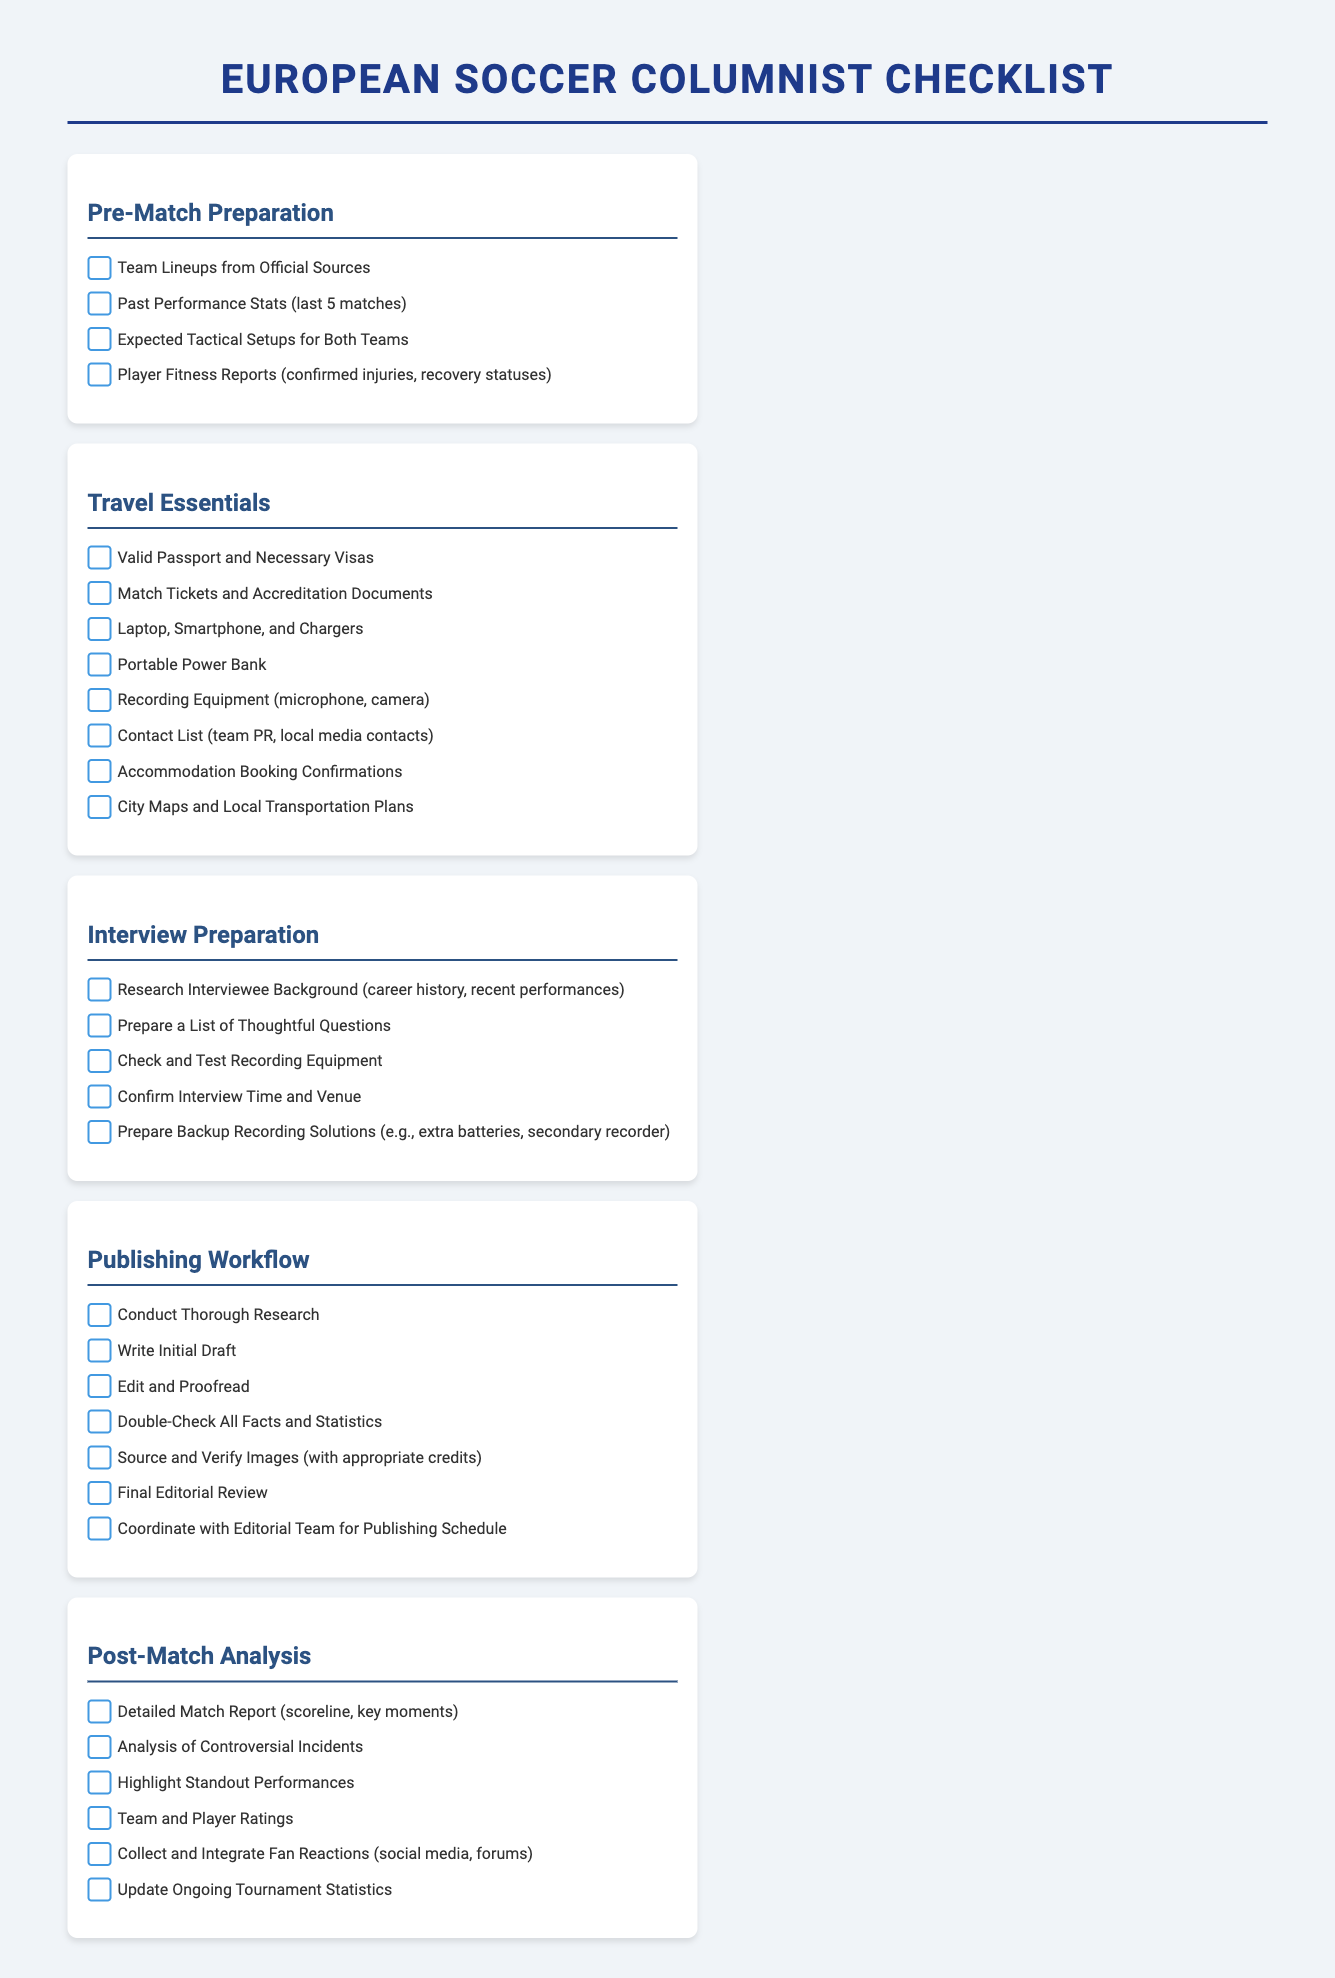What are the two topics covered under the checklist for pre-match preparation? The pre-match preparation checklist includes necessary insights such as team lineups and past performance stats.
Answer: Team Lineups, Past Performance Stats How many items are listed under the travel essentials checklist? There are eight essential items listed that are required for traveling.
Answer: 8 What is one type of equipment mentioned for recording interviews? The checklist specifies recording equipment, which typically includes microphones.
Answer: Microphone What step comes after writing the initial draft in the publishing workflow? The next step after the initial draft is editing and proofreading the content.
Answer: Edit and Proofread Which section of the document focuses specifically on team and player ratings? The post-match analysis checklist specifically addresses team and player ratings.
Answer: Post-Match Analysis What is the main purpose of the document? This document serves as a comprehensive checklist for a European soccer columnist.
Answer: Checklist How many key aspects are highlighted in the post-match analysis checklist? There are six key aspects covered in the post-match analysis checklist.
Answer: 6 What document is needed alongside valid passports for travel? Accreditation documents are also necessary for travel to cover matches.
Answer: Accreditation Documents 